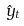<formula> <loc_0><loc_0><loc_500><loc_500>\hat { y } _ { t }</formula> 